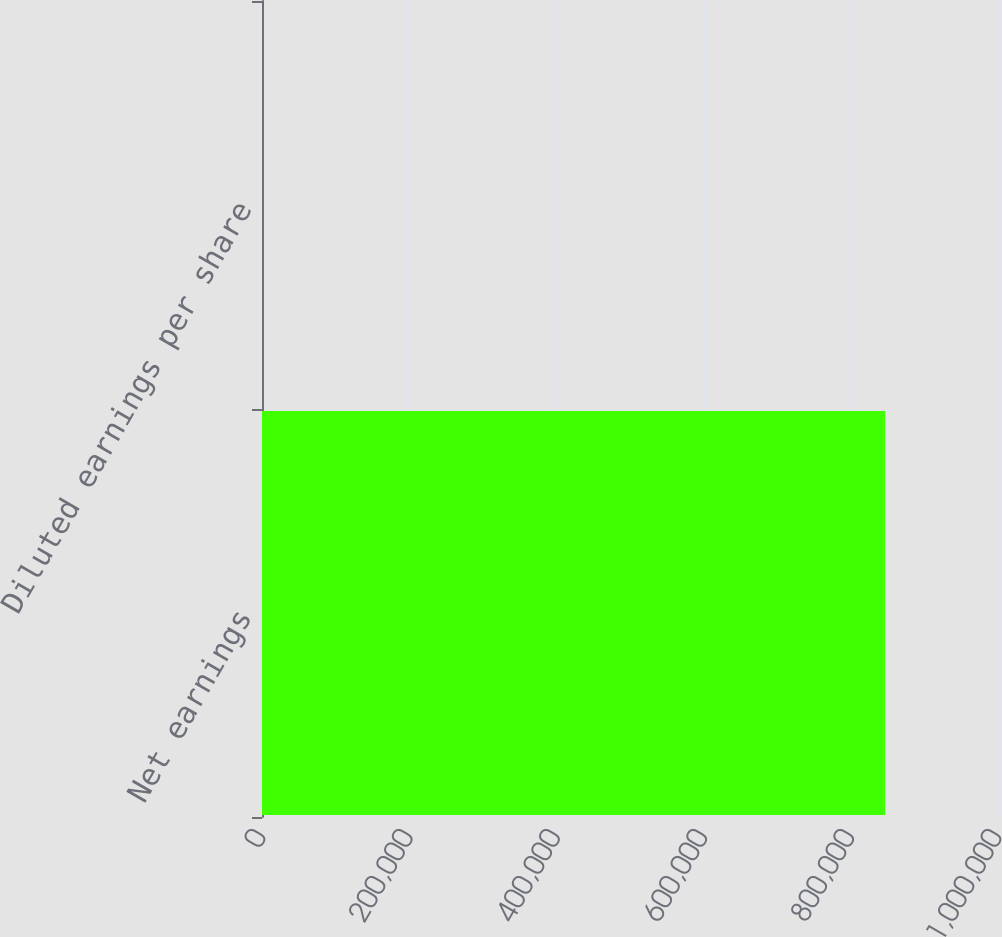<chart> <loc_0><loc_0><loc_500><loc_500><bar_chart><fcel>Net earnings<fcel>Diluted earnings per share<nl><fcel>846735<fcel>1.57<nl></chart> 